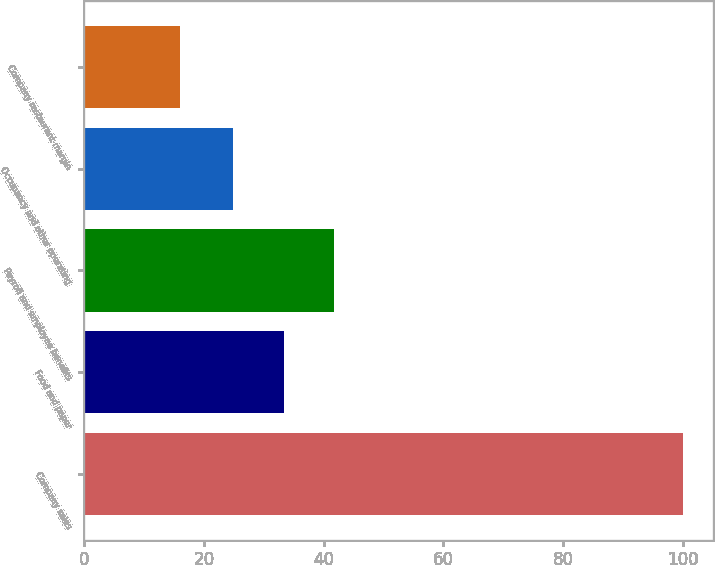Convert chart to OTSL. <chart><loc_0><loc_0><loc_500><loc_500><bar_chart><fcel>Company sales<fcel>Food and paper<fcel>Payroll and employee benefits<fcel>Occupancy and other operating<fcel>Company restaurant margin<nl><fcel>100<fcel>33.3<fcel>41.7<fcel>24.9<fcel>16<nl></chart> 